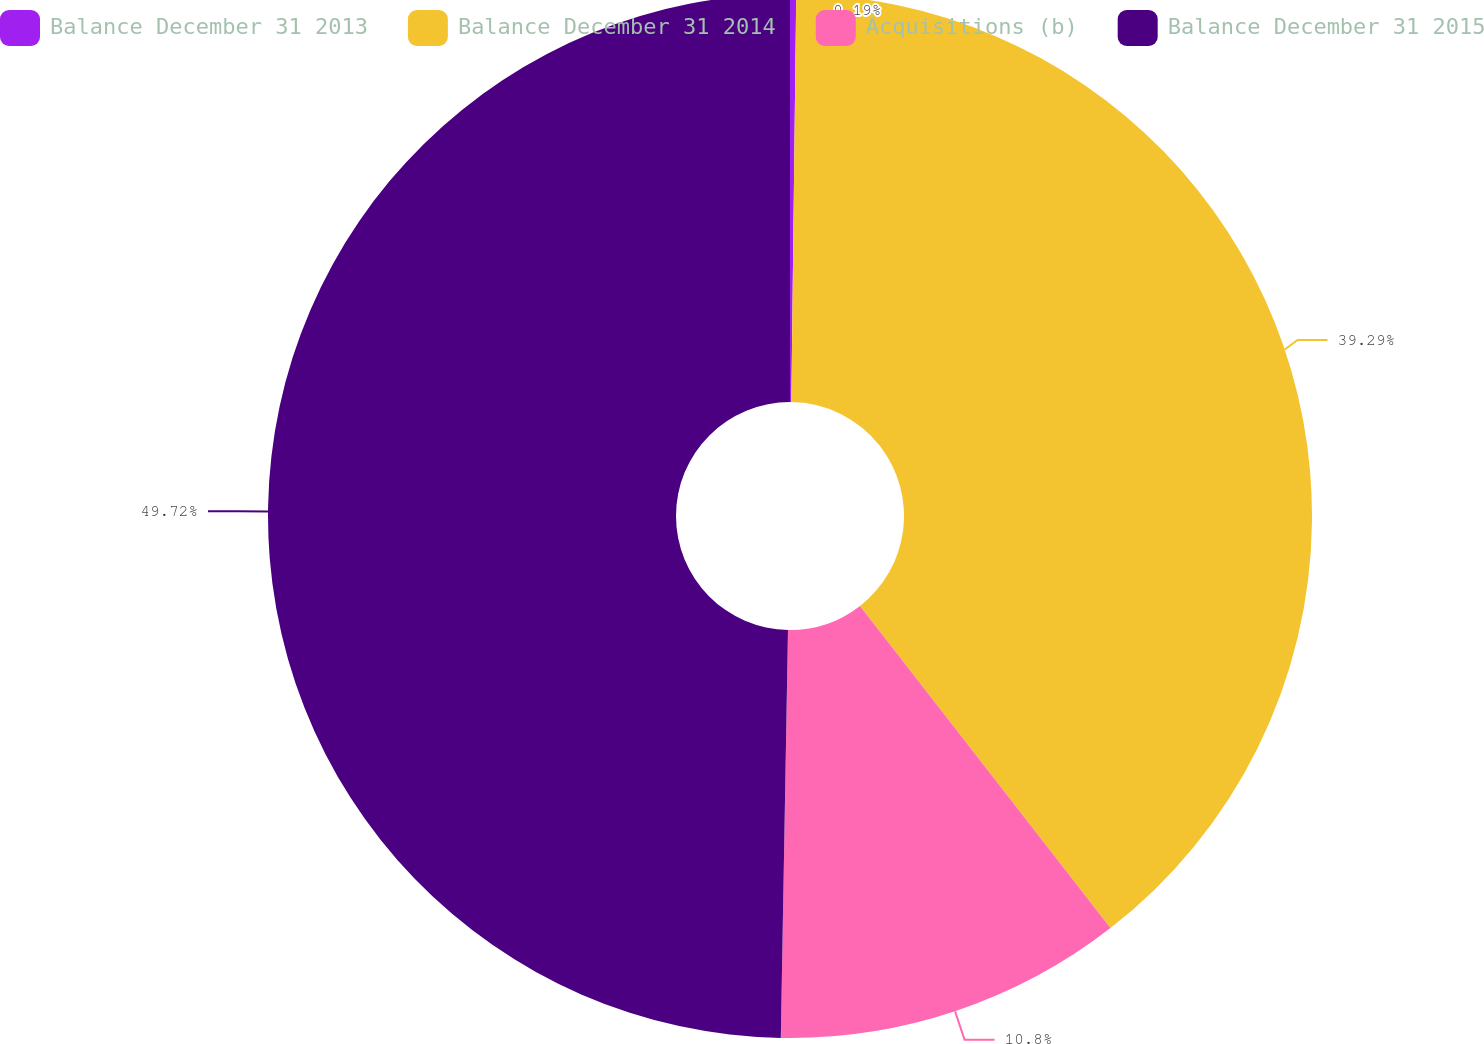Convert chart to OTSL. <chart><loc_0><loc_0><loc_500><loc_500><pie_chart><fcel>Balance December 31 2013<fcel>Balance December 31 2014<fcel>Acquisitions (b)<fcel>Balance December 31 2015<nl><fcel>0.19%<fcel>39.29%<fcel>10.8%<fcel>49.72%<nl></chart> 